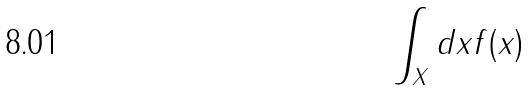Convert formula to latex. <formula><loc_0><loc_0><loc_500><loc_500>\int _ { X } d x f ( x )</formula> 